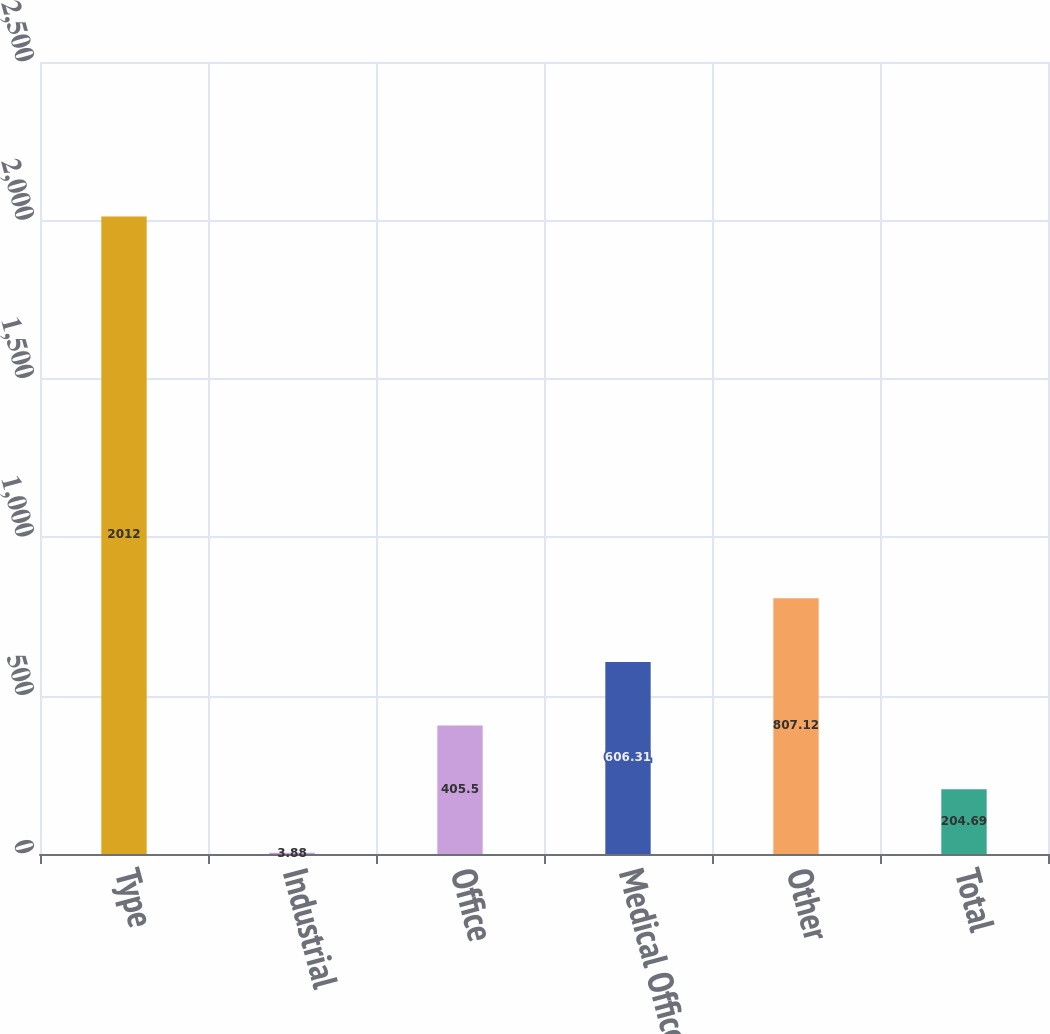Convert chart. <chart><loc_0><loc_0><loc_500><loc_500><bar_chart><fcel>Type<fcel>Industrial<fcel>Office<fcel>Medical Office<fcel>Other<fcel>Total<nl><fcel>2012<fcel>3.88<fcel>405.5<fcel>606.31<fcel>807.12<fcel>204.69<nl></chart> 